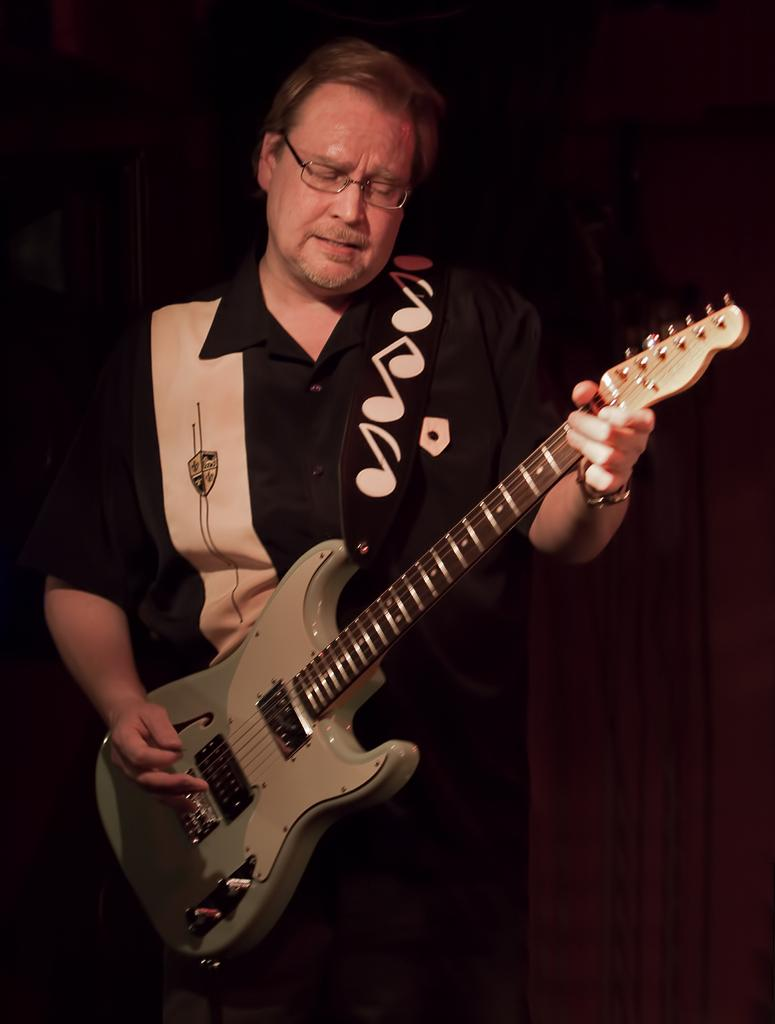What is the main subject of the image? There is a person in the image. What is the person doing in the image? The person is playing a guitar. How would you describe the background of the image? The background of the image is dark orange in color. When was the image taken? The image was taken during night time. How many kittens are sitting on the person's knee in the image? There are no kittens present in the image, and the person's knee is not visible. What event is being celebrated in the image? There is no indication of a specific event being celebrated in the image. 